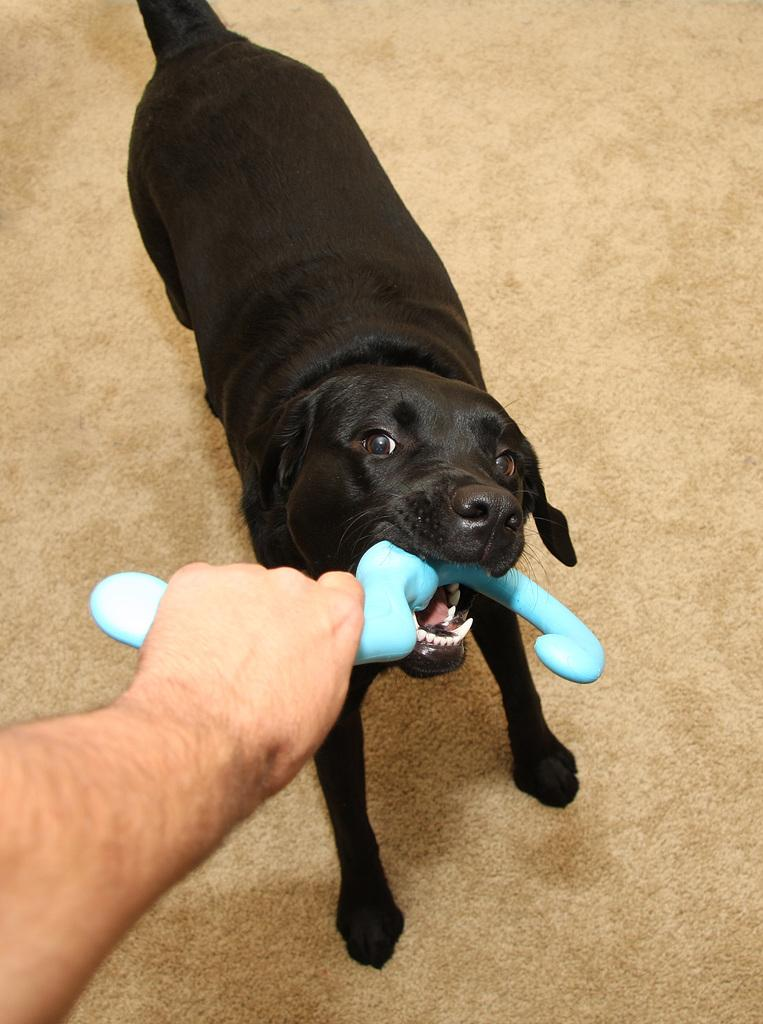What is the person's hand holding in the image? There is a person's hand holding an object in the image. What type of animal is present in the image? There is a dog in the image. What is the dog doing in the image? The dog is baiting an object. Where is the control panel for the bedroom located in the image? There is no control panel or bedroom present in the image; it features a person's hand holding an object and a dog baiting an object. 